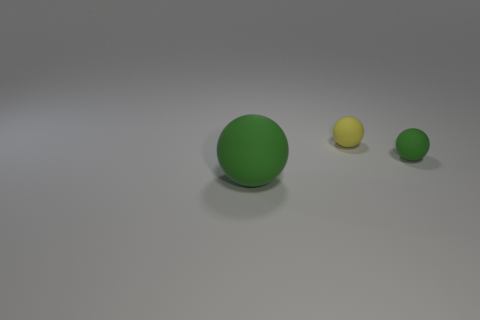What number of other objects are there of the same shape as the yellow object?
Provide a short and direct response. 2. There is a object in front of the small green matte object; is its color the same as the sphere that is right of the yellow ball?
Offer a terse response. Yes. What is the size of the matte ball behind the tiny matte sphere in front of the small matte thing to the left of the tiny green rubber ball?
Provide a short and direct response. Small. The thing that is both behind the large thing and on the left side of the tiny green object has what shape?
Your response must be concise. Sphere. Are there an equal number of matte spheres that are behind the yellow matte object and large green matte balls that are right of the large rubber ball?
Your answer should be very brief. Yes. Are there any small yellow balls that have the same material as the large green object?
Your answer should be very brief. Yes. Do the thing on the left side of the yellow matte sphere and the small green sphere have the same material?
Your answer should be compact. Yes. There is a matte sphere that is both in front of the small yellow matte ball and behind the large matte object; what size is it?
Your response must be concise. Small. What color is the large object?
Ensure brevity in your answer.  Green. How many small yellow matte spheres are there?
Ensure brevity in your answer.  1. 